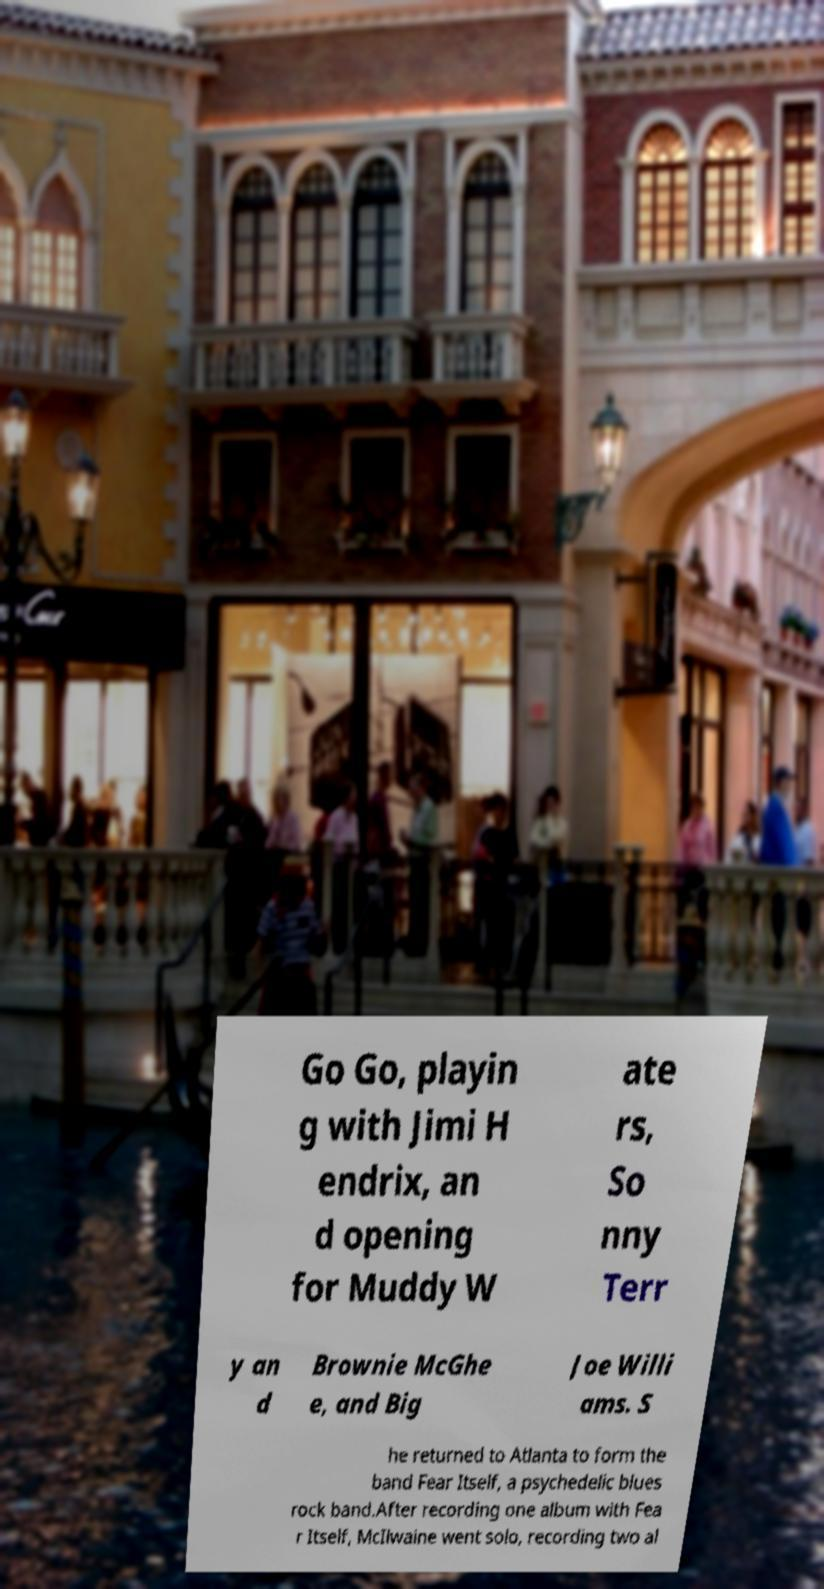I need the written content from this picture converted into text. Can you do that? Go Go, playin g with Jimi H endrix, an d opening for Muddy W ate rs, So nny Terr y an d Brownie McGhe e, and Big Joe Willi ams. S he returned to Atlanta to form the band Fear Itself, a psychedelic blues rock band.After recording one album with Fea r Itself, McIlwaine went solo, recording two al 